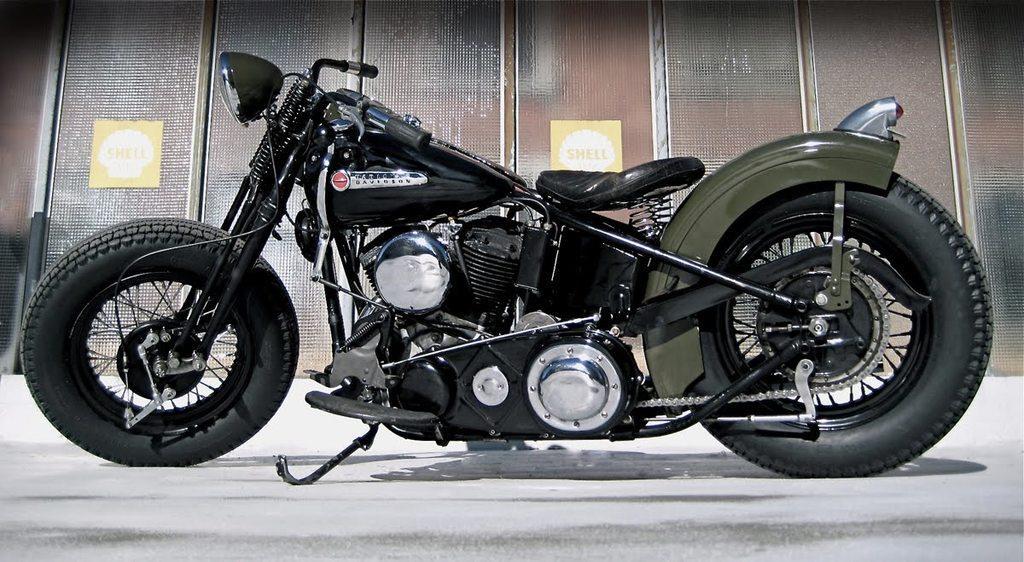Please provide a concise description of this image. In this image I can see a green and black colour motorcycle in the front. In the background I can see two boards on the wall and on these words I can see something is written. 